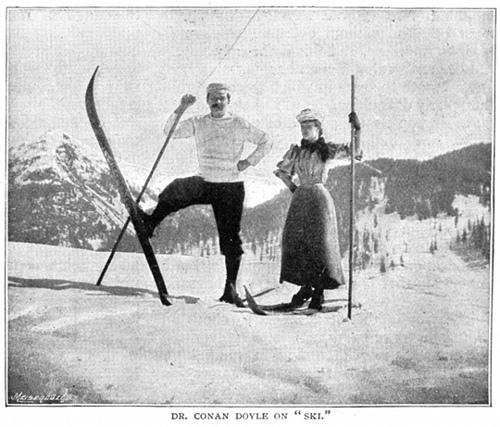Identify the main activity taking place in the image and the people involved. A couple is skiing together in the snow, with a man looking happy and a woman enjoying herself. Can you describe the scenery in the image as a caption? A clear and sunny day with mountains in the background, bright white snow-covered ground, and trees along the horizon. For a multi-choice VQA task, what is an appropriate question about the image, along with four possible answers, including the correct one? What is the weather like in the image? A) Rainy B) Clear and sunny C) Snowy D) Overcast Mention the clothing items the man is wearing in the image. The man is wearing a white long-sleeve shirt, dark pants, and is holding a long ski pole. What are the different captions that can describe the couple in the image? "A couple enjoying a sunny ski day," "A moment of joy on the snowy slopes," "Skiing together in the mountains," "A leisurely ski outing for two." What can you say about the clothing and accessories worn by the lady in the image? The lady is wearing a dark long coat, a light-colored hat, and is holding a ski pole. She has skis on her feet. Create a poetic description of the scenery in the image. "Beneath the vast, azure sky, the mountains stand majestic, the snow glistens bright, where a couple finds joy in winter's embrace." Find an object in the image, and create a referential expression grounding caption for it. "The long ski pole the man is holding helps him balance on the snowy terrain." What would be a suitable product advertisement caption for the image? "Embrace the thrill of the mountains with our durable skis and stylish winter wear!" Write a short story about the couple in the image. Once upon a clear and sunny day, a loving couple decided to spend an adventurous day skiing together. As they glided through the bright white, snow-covered ground, they laughed and smiled, with the breathtaking mountains as their backdrop. The trees along the horizon added to their picturesque surroundings, and their love for each other and the sport grew even stronger. 